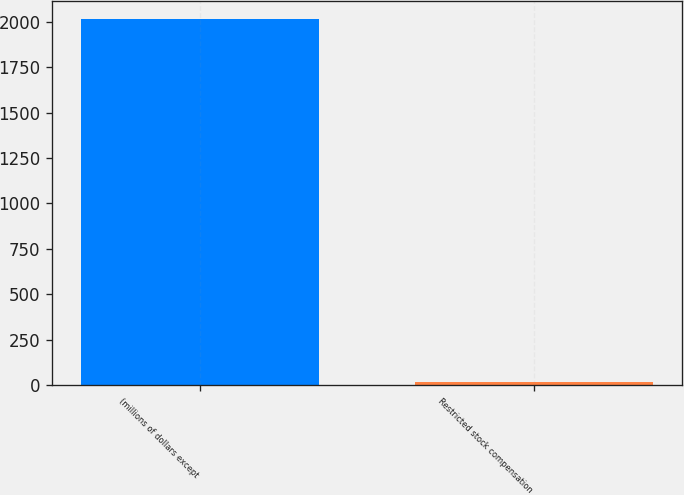<chart> <loc_0><loc_0><loc_500><loc_500><bar_chart><fcel>(millions of dollars except<fcel>Restricted stock compensation<nl><fcel>2013<fcel>18.8<nl></chart> 